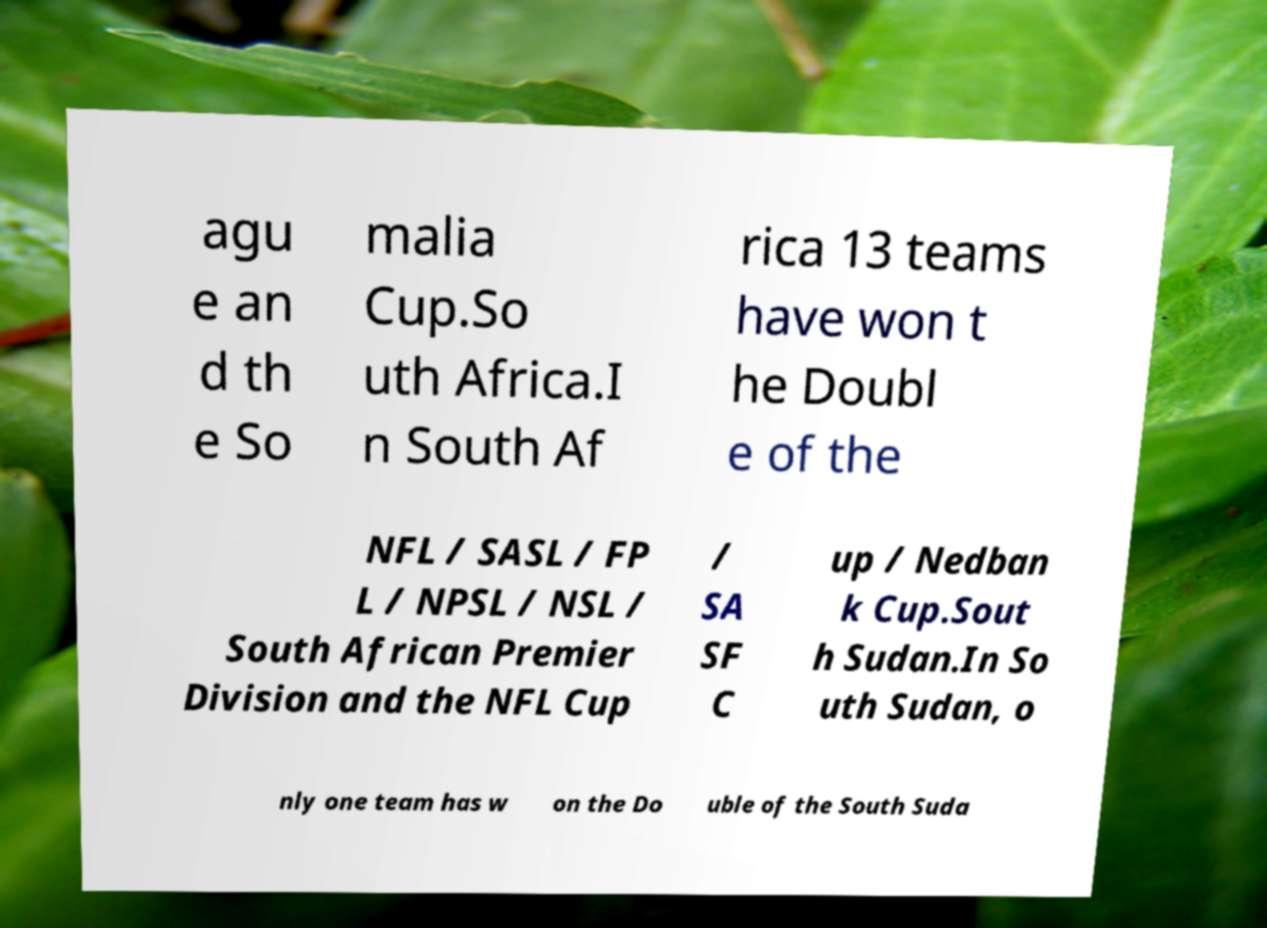What messages or text are displayed in this image? I need them in a readable, typed format. agu e an d th e So malia Cup.So uth Africa.I n South Af rica 13 teams have won t he Doubl e of the NFL / SASL / FP L / NPSL / NSL / South African Premier Division and the NFL Cup / SA SF C up / Nedban k Cup.Sout h Sudan.In So uth Sudan, o nly one team has w on the Do uble of the South Suda 